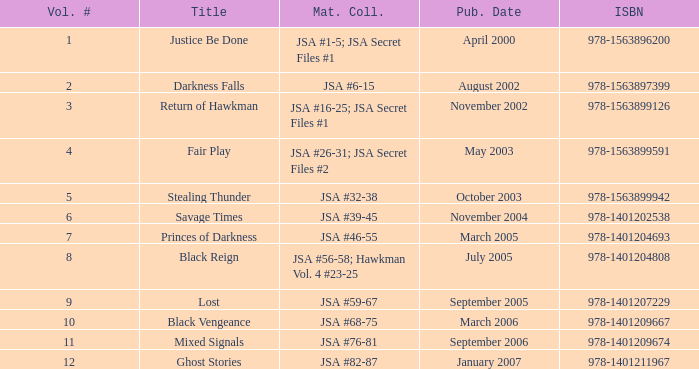What's the Lowest Volume Number that was published November 2004? 6.0. 